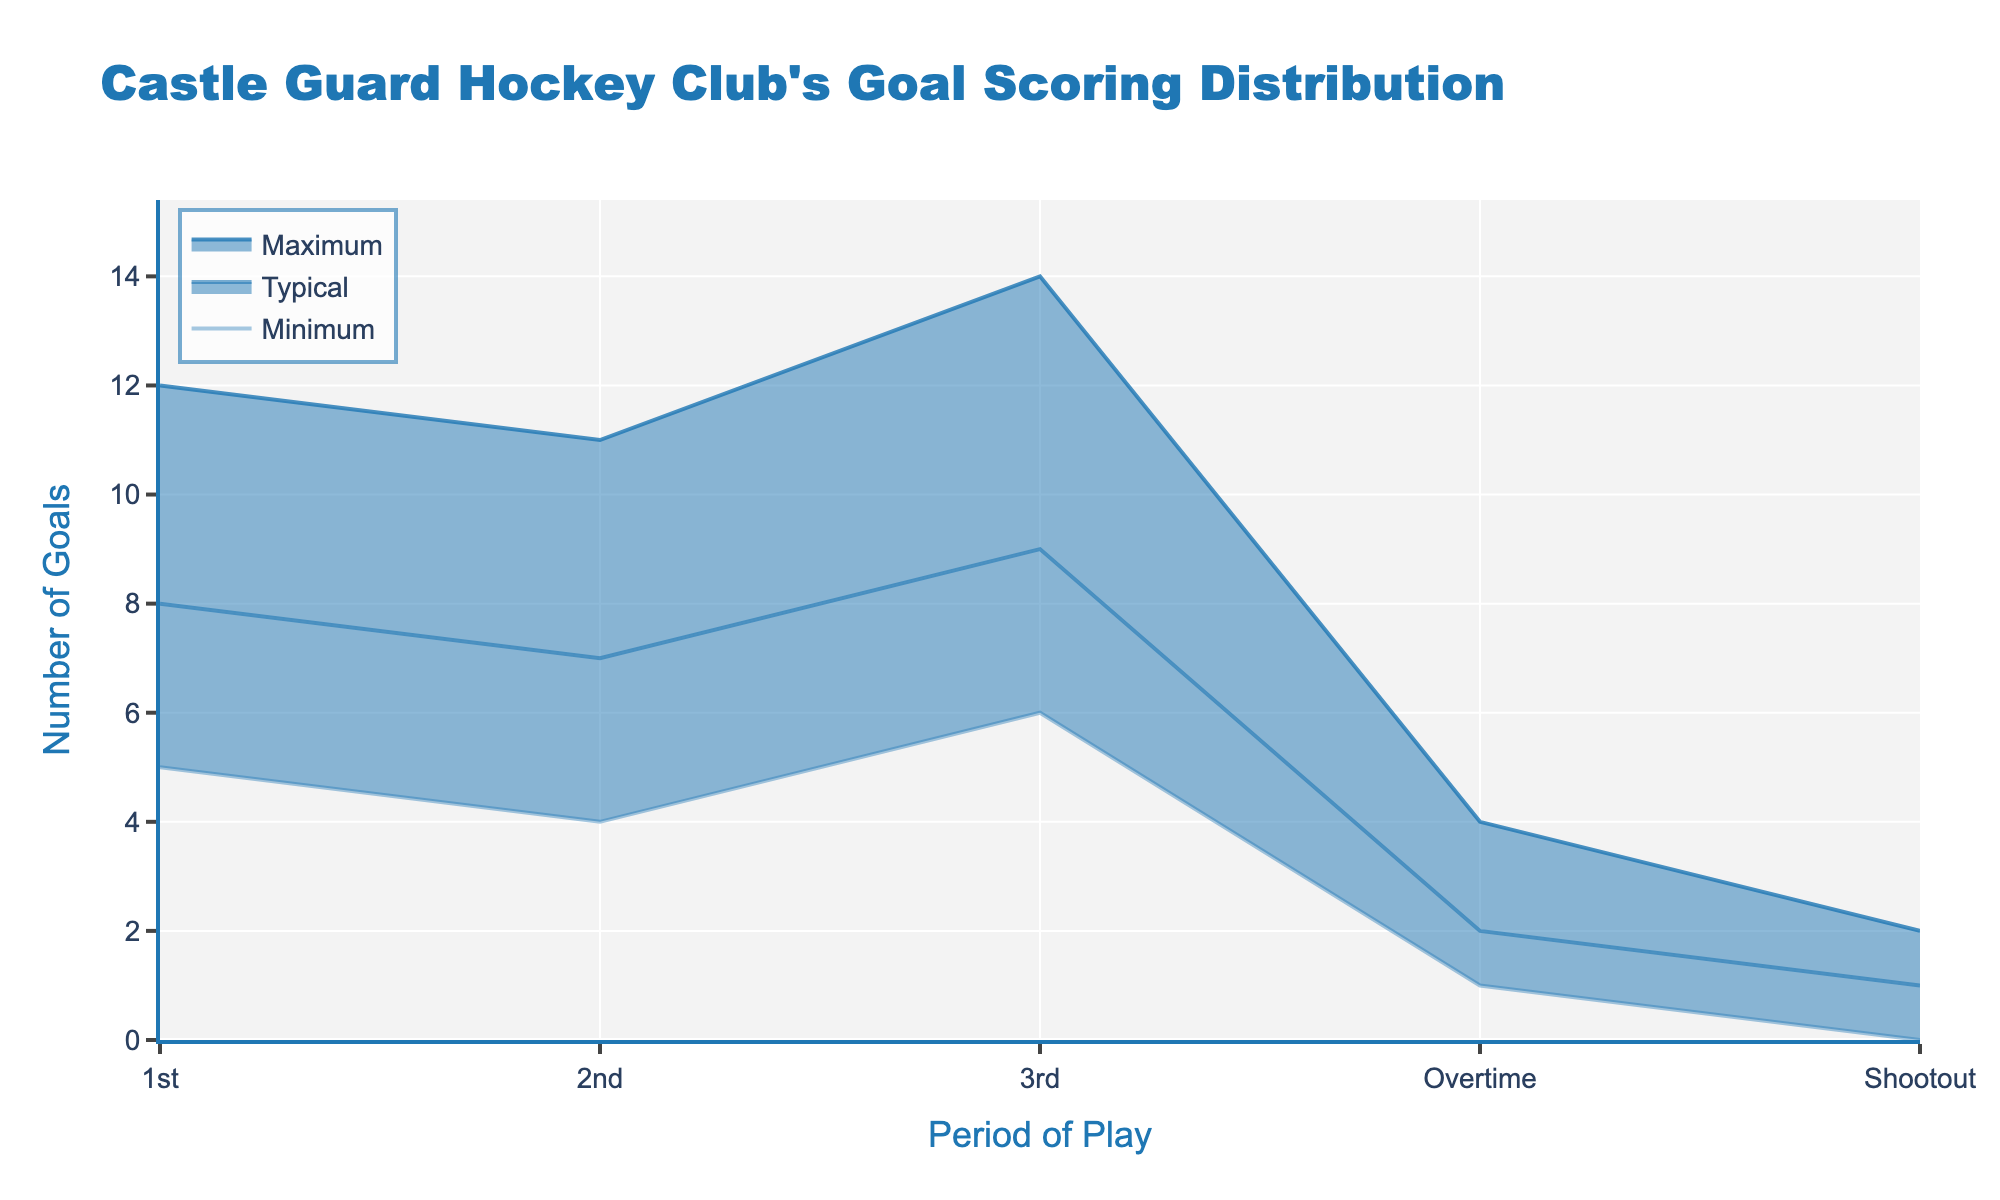What is the title of the figure? The title is displayed at the top of the figure and provides the name of the data being visualized.
Answer: Castle Guard Hockey Club's Goal Scoring Distribution What periods of play are shown in the figure? The figure has an axis that lists different periods of play from the start to potential extra time. Reviewing the x-axis provides the periods.
Answer: 1st, 2nd, 3rd, Overtime, Shootout What is the maximum number of goals scored in the 2nd period? To find this, one needs to look at the line representing 'Maximum' goals during the 2nd period. It’s marked on the y-axis directly above "2nd".
Answer: 11 Which period has the highest typical number of goals scored? The typical number of goals scored is represented by the middle line of the filled region. Look for the period where this line peaks.
Answer: 3rd period What is the difference between the maximum and minimum number of goals scored in the 1st period? We subtract the minimum number of goals from the maximum for the 1st period by referencing the respective y-values. Max is 12 and Min is 5.
Answer: 7 In which period is the goal distribution the most narrow? The narrowness can be determined by examining where the range between the minimum and maximum lines is the smallest. Visual inspection shows this narrow range.
Answer: Shootout How does the typical number of goals scored in Overtime compare to the typical number in the 1st period? Compare the typical values for these periods shown as the middle lines. The Overtime period shows 2 goals, whereas the 1st period shows 8 goals.
Answer: The 1st period has a higher typical number of goals scored than Overtime What is the average minimum number of goals across all periods? Add each period's minimum number of goals and then divide by the number of periods (5+4+6+1+0) / 5 = 16/5.
Answer: 3.2 What is the range of goals scored during the Shootout period? The range is calculated by subtracting the minimum from the maximum number of goals for the Shootout period, which are 2 and 0 respectively.
Answer: 2 In which periods does the minimum number of goals exceed 4? Evaluate the y-values for minimum goals for each period to identify those greater than 4. This applies to the 1st and 3rd periods.
Answer: 1st and 3rd periods 